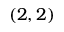<formula> <loc_0><loc_0><loc_500><loc_500>( 2 , 2 )</formula> 